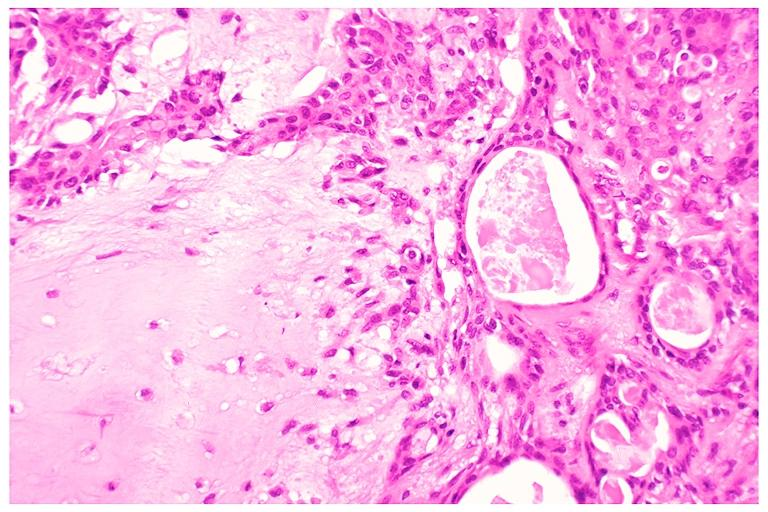where is this?
Answer the question using a single word or phrase. Oral 